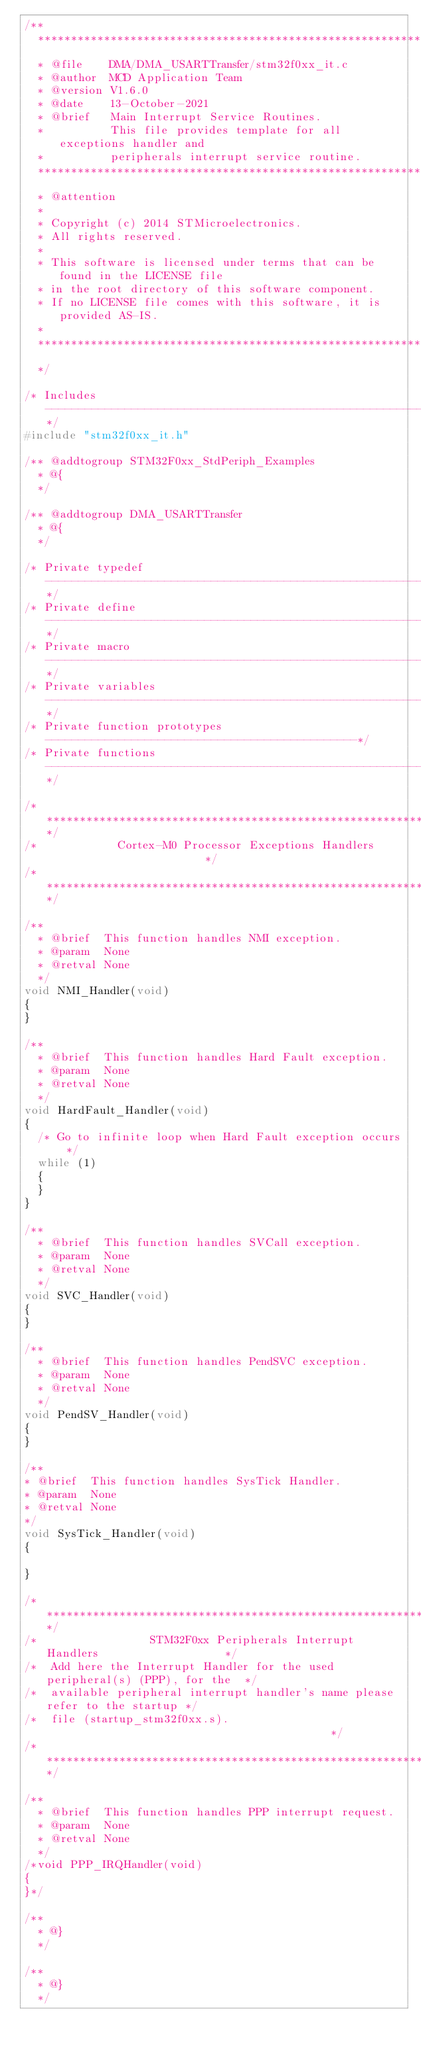Convert code to text. <code><loc_0><loc_0><loc_500><loc_500><_C_>/**
  ******************************************************************************
  * @file    DMA/DMA_USARTTransfer/stm32f0xx_it.c 
  * @author  MCD Application Team
  * @version V1.6.0
  * @date    13-October-2021
  * @brief   Main Interrupt Service Routines.
  *          This file provides template for all exceptions handler and 
  *          peripherals interrupt service routine.
  ******************************************************************************
  * @attention
  *
  * Copyright (c) 2014 STMicroelectronics.
  * All rights reserved.
  *
  * This software is licensed under terms that can be found in the LICENSE file
  * in the root directory of this software component.
  * If no LICENSE file comes with this software, it is provided AS-IS.
  *
  ******************************************************************************
  */

/* Includes ------------------------------------------------------------------*/
#include "stm32f0xx_it.h"

/** @addtogroup STM32F0xx_StdPeriph_Examples
  * @{
  */

/** @addtogroup DMA_USARTTransfer
  * @{
  */

/* Private typedef -----------------------------------------------------------*/
/* Private define ------------------------------------------------------------*/
/* Private macro -------------------------------------------------------------*/
/* Private variables ---------------------------------------------------------*/
/* Private function prototypes -----------------------------------------------*/
/* Private functions ---------------------------------------------------------*/

/******************************************************************************/
/*            Cortex-M0 Processor Exceptions Handlers                         */
/******************************************************************************/

/**
  * @brief  This function handles NMI exception.
  * @param  None
  * @retval None
  */
void NMI_Handler(void)
{
}

/**
  * @brief  This function handles Hard Fault exception.
  * @param  None
  * @retval None
  */
void HardFault_Handler(void)
{
  /* Go to infinite loop when Hard Fault exception occurs */
  while (1)
  {
  }
}

/**
  * @brief  This function handles SVCall exception.
  * @param  None
  * @retval None
  */
void SVC_Handler(void)
{
}

/**
  * @brief  This function handles PendSVC exception.
  * @param  None
  * @retval None
  */
void PendSV_Handler(void)
{
}

/**
* @brief  This function handles SysTick Handler.
* @param  None
* @retval None
*/
void SysTick_Handler(void)
{   

}

/******************************************************************************/
/*                 STM32F0xx Peripherals Interrupt Handlers                   */
/*  Add here the Interrupt Handler for the used peripheral(s) (PPP), for the  */
/*  available peripheral interrupt handler's name please refer to the startup */
/*  file (startup_stm32f0xx.s).                                            */
/******************************************************************************/

/**
  * @brief  This function handles PPP interrupt request.
  * @param  None
  * @retval None
  */
/*void PPP_IRQHandler(void)
{
}*/

/**
  * @}
  */

/**
  * @}
  */ 


</code> 